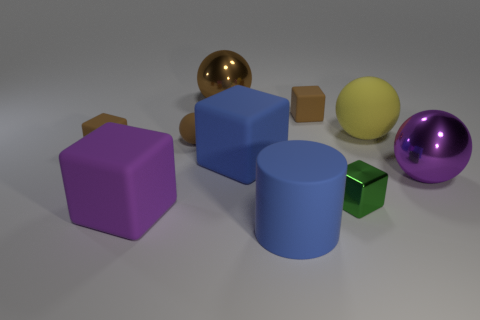Subtract all big blue rubber blocks. How many blocks are left? 4 Subtract 2 blocks. How many blocks are left? 3 Subtract all purple cubes. How many cubes are left? 4 Subtract all gray cubes. Subtract all yellow spheres. How many cubes are left? 5 Subtract all cylinders. How many objects are left? 9 Subtract 0 red blocks. How many objects are left? 10 Subtract all small yellow metallic things. Subtract all matte things. How many objects are left? 3 Add 2 small brown matte spheres. How many small brown matte spheres are left? 3 Add 6 large blue matte things. How many large blue matte things exist? 8 